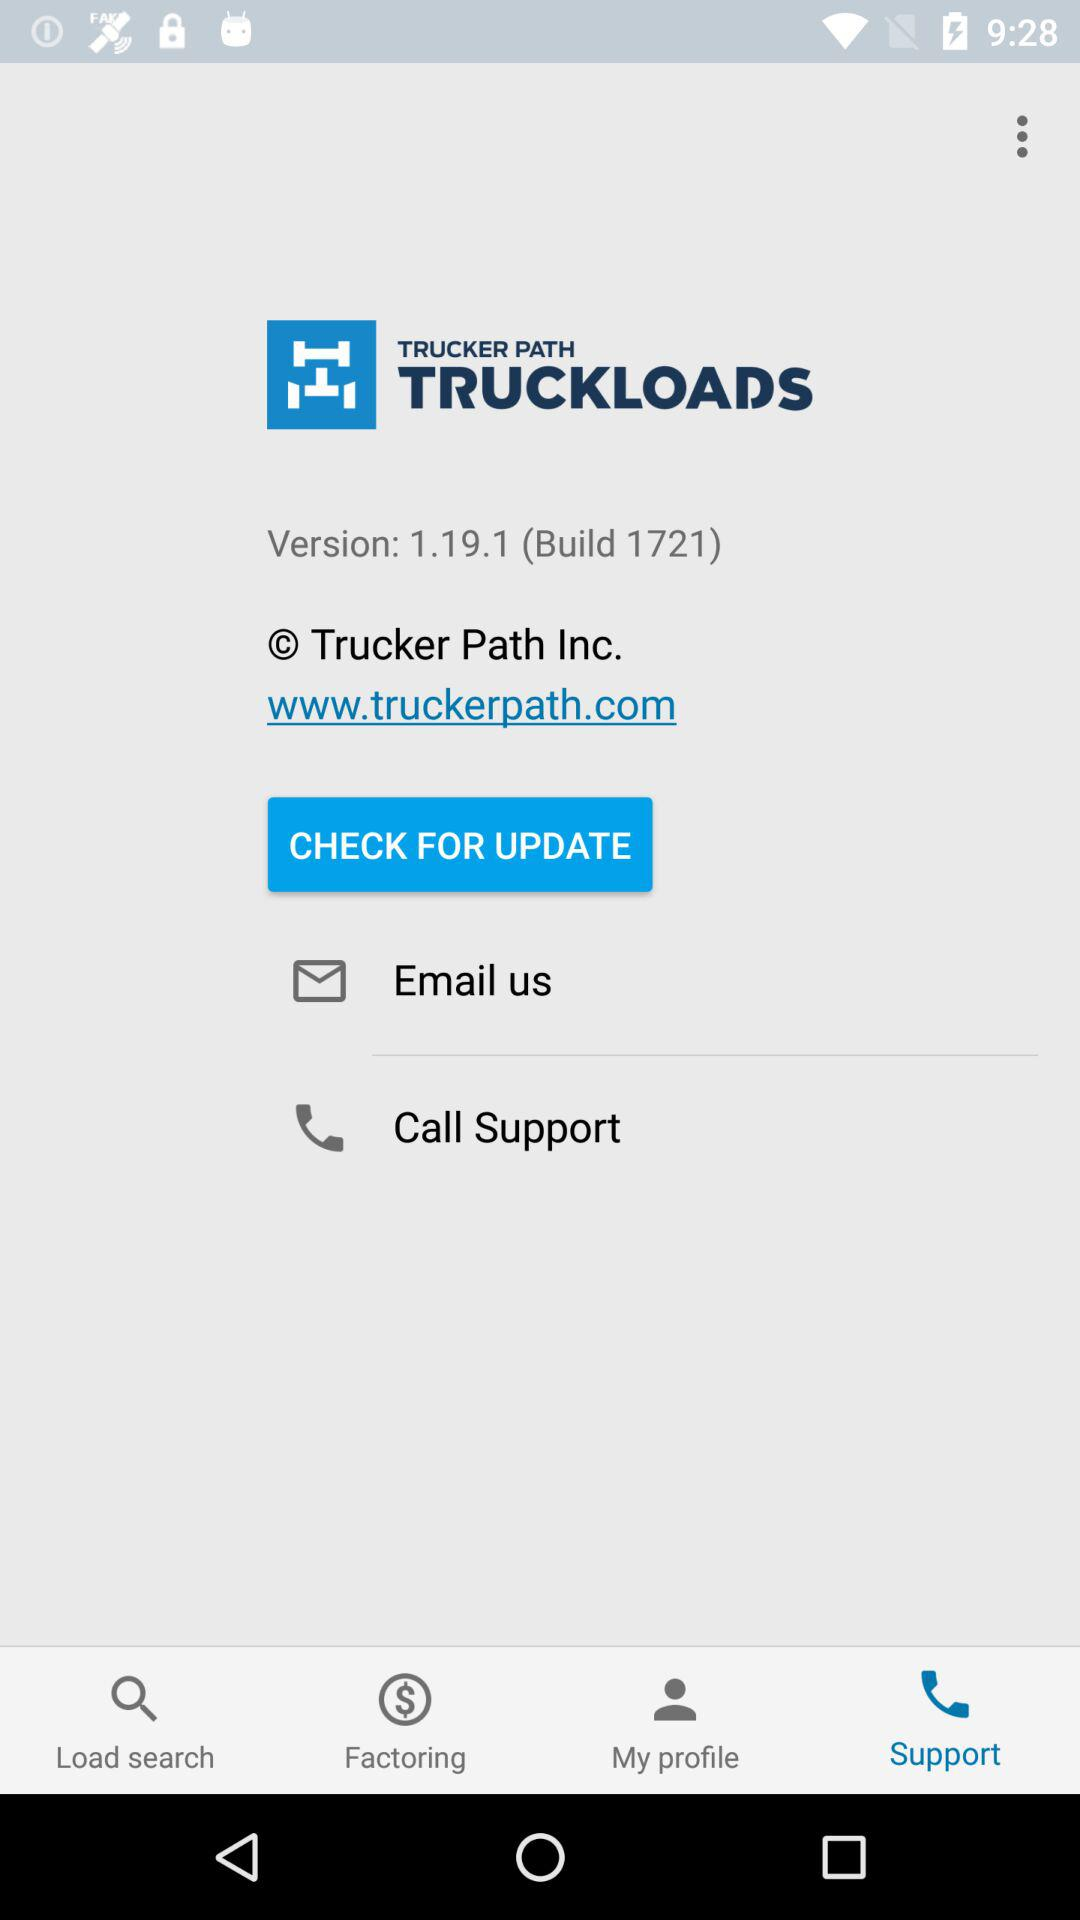What is the version? The version is 1.19.1 (Build 1721). 